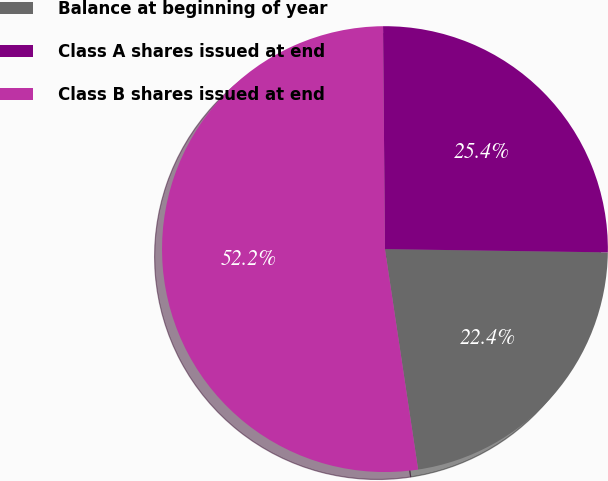Convert chart. <chart><loc_0><loc_0><loc_500><loc_500><pie_chart><fcel>Balance at beginning of year<fcel>Class A shares issued at end<fcel>Class B shares issued at end<nl><fcel>22.39%<fcel>25.37%<fcel>52.24%<nl></chart> 